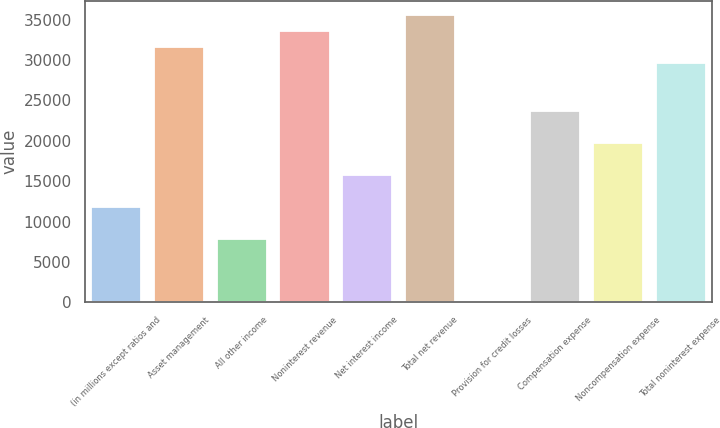Convert chart to OTSL. <chart><loc_0><loc_0><loc_500><loc_500><bar_chart><fcel>(in millions except ratios and<fcel>Asset management<fcel>All other income<fcel>Noninterest revenue<fcel>Net interest income<fcel>Total net revenue<fcel>Provision for credit losses<fcel>Compensation expense<fcel>Noncompensation expense<fcel>Total noninterest expense<nl><fcel>11842.6<fcel>31573.6<fcel>7896.4<fcel>33546.7<fcel>15788.8<fcel>35519.8<fcel>4<fcel>23681.2<fcel>19735<fcel>29600.5<nl></chart> 